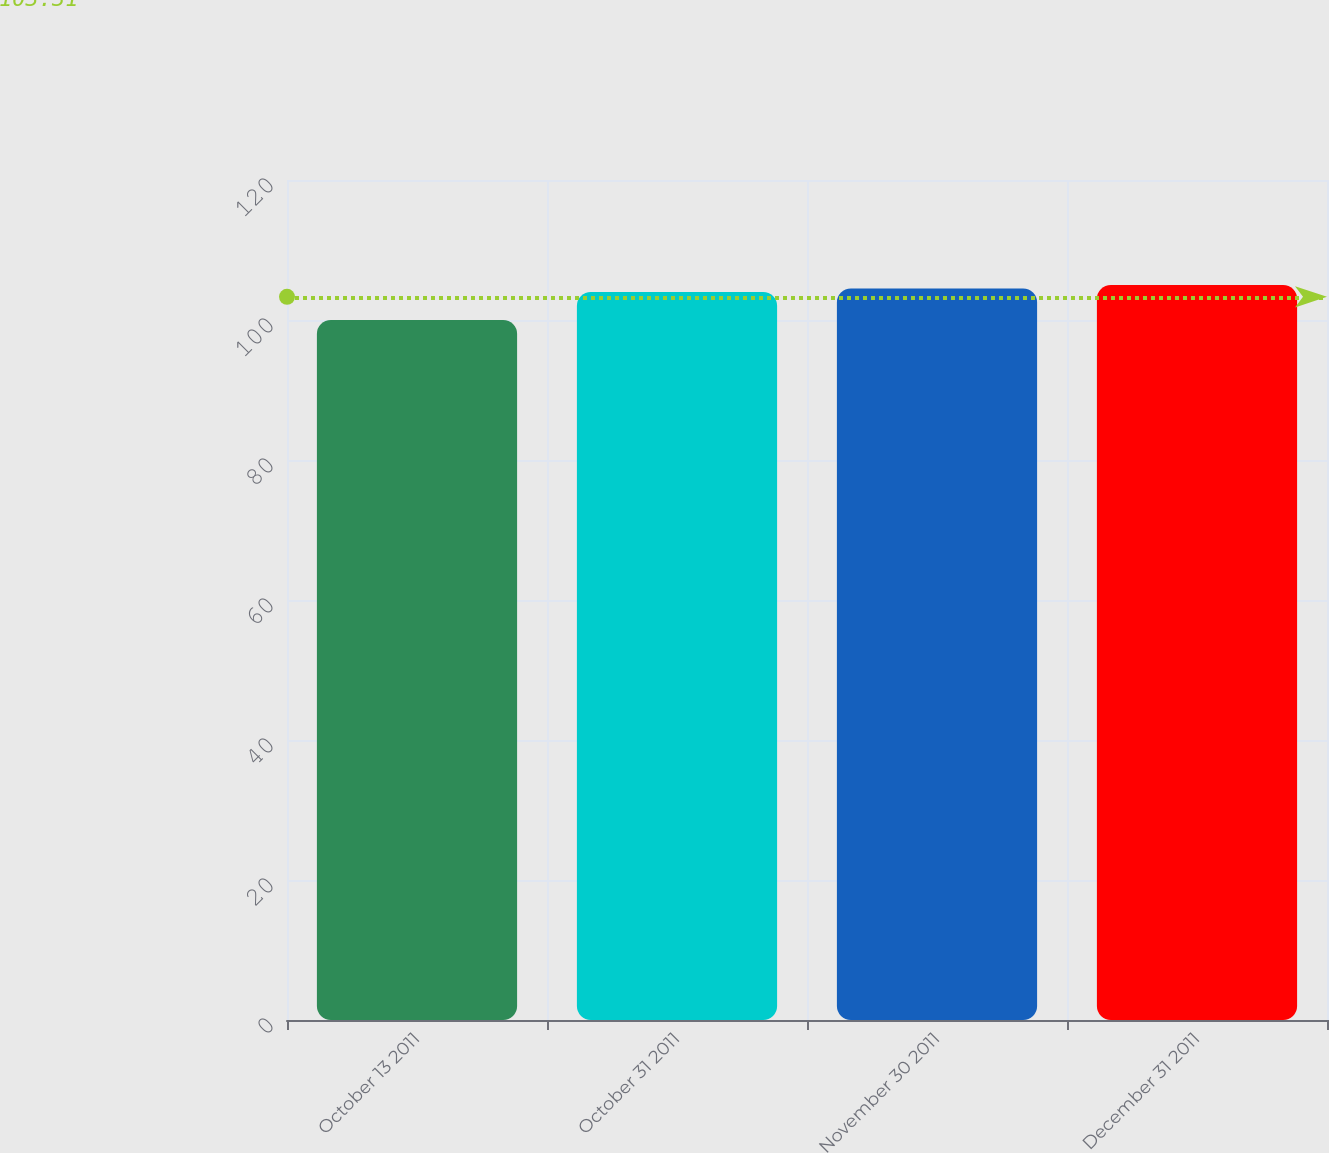Convert chart. <chart><loc_0><loc_0><loc_500><loc_500><bar_chart><fcel>October 13 2011<fcel>October 31 2011<fcel>November 30 2011<fcel>December 31 2011<nl><fcel>100<fcel>104<fcel>104.5<fcel>105<nl></chart> 